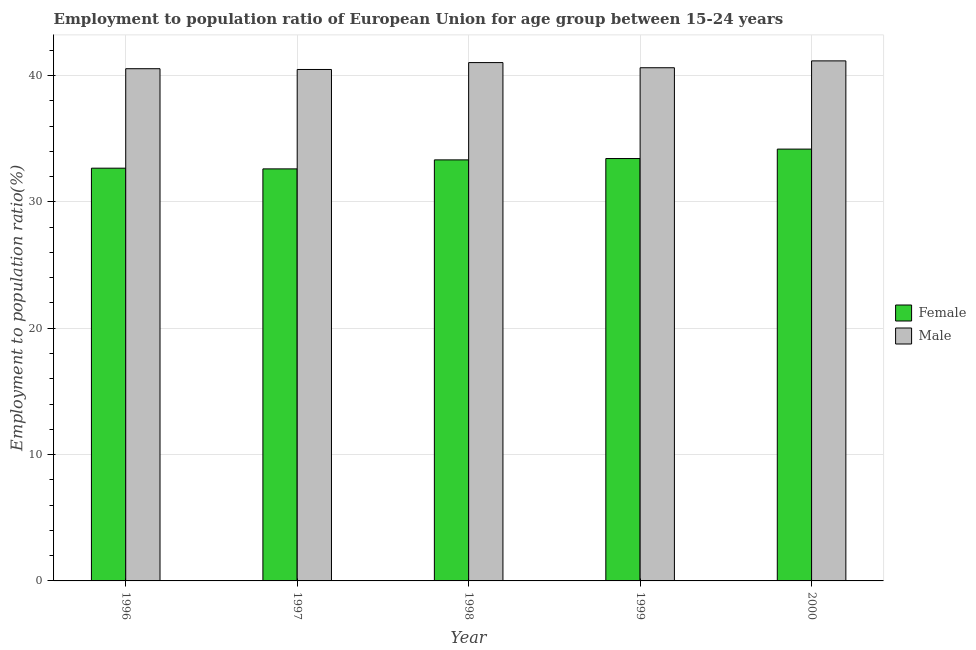How many groups of bars are there?
Keep it short and to the point. 5. Are the number of bars per tick equal to the number of legend labels?
Your answer should be very brief. Yes. How many bars are there on the 3rd tick from the right?
Ensure brevity in your answer.  2. What is the label of the 4th group of bars from the left?
Your response must be concise. 1999. What is the employment to population ratio(female) in 1998?
Provide a short and direct response. 33.33. Across all years, what is the maximum employment to population ratio(male)?
Your answer should be very brief. 41.16. Across all years, what is the minimum employment to population ratio(female)?
Offer a very short reply. 32.62. In which year was the employment to population ratio(female) maximum?
Ensure brevity in your answer.  2000. What is the total employment to population ratio(female) in the graph?
Offer a terse response. 166.23. What is the difference between the employment to population ratio(male) in 1997 and that in 1999?
Provide a succinct answer. -0.14. What is the difference between the employment to population ratio(female) in 1996 and the employment to population ratio(male) in 2000?
Your response must be concise. -1.51. What is the average employment to population ratio(female) per year?
Keep it short and to the point. 33.25. In the year 1997, what is the difference between the employment to population ratio(male) and employment to population ratio(female)?
Give a very brief answer. 0. In how many years, is the employment to population ratio(male) greater than 14 %?
Your answer should be very brief. 5. What is the ratio of the employment to population ratio(female) in 1996 to that in 1999?
Your response must be concise. 0.98. Is the employment to population ratio(male) in 1997 less than that in 1999?
Offer a terse response. Yes. What is the difference between the highest and the second highest employment to population ratio(male)?
Your answer should be very brief. 0.13. What is the difference between the highest and the lowest employment to population ratio(male)?
Keep it short and to the point. 0.68. In how many years, is the employment to population ratio(female) greater than the average employment to population ratio(female) taken over all years?
Your answer should be compact. 3. What does the 1st bar from the left in 1999 represents?
Offer a very short reply. Female. How many bars are there?
Offer a very short reply. 10. Are all the bars in the graph horizontal?
Make the answer very short. No. How many years are there in the graph?
Your response must be concise. 5. What is the difference between two consecutive major ticks on the Y-axis?
Your answer should be compact. 10. Does the graph contain grids?
Provide a succinct answer. Yes. How many legend labels are there?
Your response must be concise. 2. How are the legend labels stacked?
Your answer should be compact. Vertical. What is the title of the graph?
Give a very brief answer. Employment to population ratio of European Union for age group between 15-24 years. What is the Employment to population ratio(%) of Female in 1996?
Ensure brevity in your answer.  32.67. What is the Employment to population ratio(%) of Male in 1996?
Your response must be concise. 40.54. What is the Employment to population ratio(%) of Female in 1997?
Provide a succinct answer. 32.62. What is the Employment to population ratio(%) in Male in 1997?
Make the answer very short. 40.48. What is the Employment to population ratio(%) of Female in 1998?
Offer a terse response. 33.33. What is the Employment to population ratio(%) in Male in 1998?
Offer a very short reply. 41.03. What is the Employment to population ratio(%) of Female in 1999?
Give a very brief answer. 33.43. What is the Employment to population ratio(%) in Male in 1999?
Your answer should be compact. 40.62. What is the Employment to population ratio(%) in Female in 2000?
Provide a short and direct response. 34.18. What is the Employment to population ratio(%) in Male in 2000?
Keep it short and to the point. 41.16. Across all years, what is the maximum Employment to population ratio(%) of Female?
Offer a terse response. 34.18. Across all years, what is the maximum Employment to population ratio(%) in Male?
Your answer should be compact. 41.16. Across all years, what is the minimum Employment to population ratio(%) in Female?
Your answer should be compact. 32.62. Across all years, what is the minimum Employment to population ratio(%) of Male?
Keep it short and to the point. 40.48. What is the total Employment to population ratio(%) in Female in the graph?
Offer a terse response. 166.23. What is the total Employment to population ratio(%) in Male in the graph?
Make the answer very short. 203.84. What is the difference between the Employment to population ratio(%) of Female in 1996 and that in 1997?
Offer a very short reply. 0.06. What is the difference between the Employment to population ratio(%) of Male in 1996 and that in 1997?
Your answer should be very brief. 0.06. What is the difference between the Employment to population ratio(%) of Female in 1996 and that in 1998?
Keep it short and to the point. -0.66. What is the difference between the Employment to population ratio(%) of Male in 1996 and that in 1998?
Keep it short and to the point. -0.49. What is the difference between the Employment to population ratio(%) of Female in 1996 and that in 1999?
Make the answer very short. -0.76. What is the difference between the Employment to population ratio(%) of Male in 1996 and that in 1999?
Ensure brevity in your answer.  -0.08. What is the difference between the Employment to population ratio(%) in Female in 1996 and that in 2000?
Your answer should be very brief. -1.51. What is the difference between the Employment to population ratio(%) of Male in 1996 and that in 2000?
Offer a terse response. -0.62. What is the difference between the Employment to population ratio(%) in Female in 1997 and that in 1998?
Give a very brief answer. -0.71. What is the difference between the Employment to population ratio(%) in Male in 1997 and that in 1998?
Ensure brevity in your answer.  -0.55. What is the difference between the Employment to population ratio(%) of Female in 1997 and that in 1999?
Provide a short and direct response. -0.82. What is the difference between the Employment to population ratio(%) in Male in 1997 and that in 1999?
Provide a succinct answer. -0.14. What is the difference between the Employment to population ratio(%) of Female in 1997 and that in 2000?
Give a very brief answer. -1.57. What is the difference between the Employment to population ratio(%) in Male in 1997 and that in 2000?
Your answer should be compact. -0.68. What is the difference between the Employment to population ratio(%) of Female in 1998 and that in 1999?
Your answer should be compact. -0.11. What is the difference between the Employment to population ratio(%) in Male in 1998 and that in 1999?
Your answer should be compact. 0.41. What is the difference between the Employment to population ratio(%) in Female in 1998 and that in 2000?
Provide a short and direct response. -0.85. What is the difference between the Employment to population ratio(%) of Male in 1998 and that in 2000?
Offer a very short reply. -0.13. What is the difference between the Employment to population ratio(%) of Female in 1999 and that in 2000?
Keep it short and to the point. -0.75. What is the difference between the Employment to population ratio(%) of Male in 1999 and that in 2000?
Offer a very short reply. -0.54. What is the difference between the Employment to population ratio(%) of Female in 1996 and the Employment to population ratio(%) of Male in 1997?
Your answer should be very brief. -7.81. What is the difference between the Employment to population ratio(%) in Female in 1996 and the Employment to population ratio(%) in Male in 1998?
Make the answer very short. -8.36. What is the difference between the Employment to population ratio(%) in Female in 1996 and the Employment to population ratio(%) in Male in 1999?
Keep it short and to the point. -7.95. What is the difference between the Employment to population ratio(%) of Female in 1996 and the Employment to population ratio(%) of Male in 2000?
Provide a succinct answer. -8.49. What is the difference between the Employment to population ratio(%) in Female in 1997 and the Employment to population ratio(%) in Male in 1998?
Ensure brevity in your answer.  -8.41. What is the difference between the Employment to population ratio(%) of Female in 1997 and the Employment to population ratio(%) of Male in 1999?
Your answer should be compact. -8.01. What is the difference between the Employment to population ratio(%) in Female in 1997 and the Employment to population ratio(%) in Male in 2000?
Your response must be concise. -8.55. What is the difference between the Employment to population ratio(%) in Female in 1998 and the Employment to population ratio(%) in Male in 1999?
Provide a short and direct response. -7.29. What is the difference between the Employment to population ratio(%) of Female in 1998 and the Employment to population ratio(%) of Male in 2000?
Make the answer very short. -7.84. What is the difference between the Employment to population ratio(%) of Female in 1999 and the Employment to population ratio(%) of Male in 2000?
Provide a succinct answer. -7.73. What is the average Employment to population ratio(%) in Female per year?
Offer a very short reply. 33.25. What is the average Employment to population ratio(%) in Male per year?
Your answer should be very brief. 40.77. In the year 1996, what is the difference between the Employment to population ratio(%) in Female and Employment to population ratio(%) in Male?
Your response must be concise. -7.87. In the year 1997, what is the difference between the Employment to population ratio(%) in Female and Employment to population ratio(%) in Male?
Provide a short and direct response. -7.87. In the year 1998, what is the difference between the Employment to population ratio(%) in Female and Employment to population ratio(%) in Male?
Give a very brief answer. -7.7. In the year 1999, what is the difference between the Employment to population ratio(%) of Female and Employment to population ratio(%) of Male?
Provide a short and direct response. -7.19. In the year 2000, what is the difference between the Employment to population ratio(%) in Female and Employment to population ratio(%) in Male?
Your answer should be compact. -6.98. What is the ratio of the Employment to population ratio(%) of Female in 1996 to that in 1998?
Ensure brevity in your answer.  0.98. What is the ratio of the Employment to population ratio(%) in Male in 1996 to that in 1998?
Make the answer very short. 0.99. What is the ratio of the Employment to population ratio(%) in Female in 1996 to that in 1999?
Provide a short and direct response. 0.98. What is the ratio of the Employment to population ratio(%) of Male in 1996 to that in 1999?
Give a very brief answer. 1. What is the ratio of the Employment to population ratio(%) of Female in 1996 to that in 2000?
Your response must be concise. 0.96. What is the ratio of the Employment to population ratio(%) in Male in 1996 to that in 2000?
Keep it short and to the point. 0.98. What is the ratio of the Employment to population ratio(%) in Female in 1997 to that in 1998?
Make the answer very short. 0.98. What is the ratio of the Employment to population ratio(%) in Male in 1997 to that in 1998?
Provide a short and direct response. 0.99. What is the ratio of the Employment to population ratio(%) of Female in 1997 to that in 1999?
Ensure brevity in your answer.  0.98. What is the ratio of the Employment to population ratio(%) of Female in 1997 to that in 2000?
Your response must be concise. 0.95. What is the ratio of the Employment to population ratio(%) of Male in 1997 to that in 2000?
Provide a short and direct response. 0.98. What is the ratio of the Employment to population ratio(%) of Female in 1998 to that in 1999?
Ensure brevity in your answer.  1. What is the ratio of the Employment to population ratio(%) in Male in 1998 to that in 1999?
Provide a short and direct response. 1.01. What is the ratio of the Employment to population ratio(%) in Female in 1998 to that in 2000?
Your answer should be very brief. 0.97. What is the ratio of the Employment to population ratio(%) in Male in 1998 to that in 2000?
Provide a succinct answer. 1. What is the ratio of the Employment to population ratio(%) of Female in 1999 to that in 2000?
Your answer should be very brief. 0.98. What is the difference between the highest and the second highest Employment to population ratio(%) of Female?
Your answer should be compact. 0.75. What is the difference between the highest and the second highest Employment to population ratio(%) in Male?
Make the answer very short. 0.13. What is the difference between the highest and the lowest Employment to population ratio(%) of Female?
Offer a very short reply. 1.57. What is the difference between the highest and the lowest Employment to population ratio(%) in Male?
Your answer should be very brief. 0.68. 